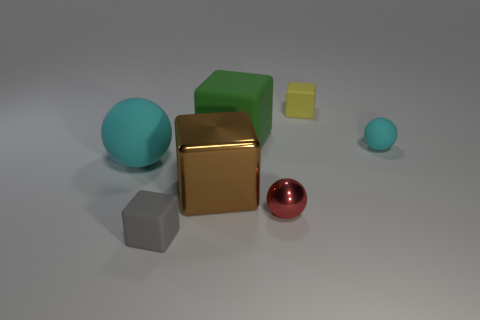Subtract all gray cubes. How many cubes are left? 3 Subtract all green spheres. Subtract all gray blocks. How many spheres are left? 3 Subtract all yellow blocks. How many blocks are left? 3 Subtract 2 blocks. How many blocks are left? 2 Subtract all cyan blocks. How many purple balls are left? 0 Subtract all large cyan cylinders. Subtract all large green matte cubes. How many objects are left? 6 Add 1 tiny rubber spheres. How many tiny rubber spheres are left? 2 Add 6 large green objects. How many large green objects exist? 7 Add 1 large metallic things. How many objects exist? 8 Subtract 0 brown cylinders. How many objects are left? 7 